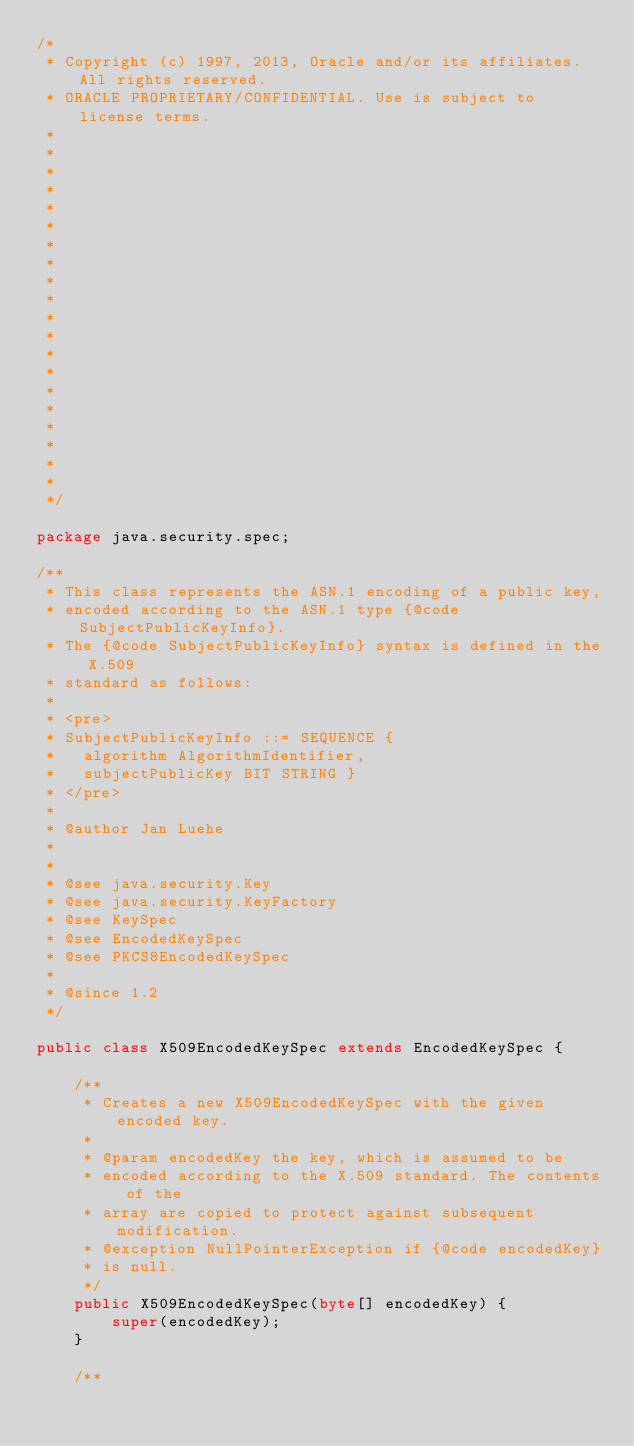Convert code to text. <code><loc_0><loc_0><loc_500><loc_500><_Java_>/*
 * Copyright (c) 1997, 2013, Oracle and/or its affiliates. All rights reserved.
 * ORACLE PROPRIETARY/CONFIDENTIAL. Use is subject to license terms.
 *
 *
 *
 *
 *
 *
 *
 *
 *
 *
 *
 *
 *
 *
 *
 *
 *
 *
 *
 *
 */

package java.security.spec;

/**
 * This class represents the ASN.1 encoding of a public key,
 * encoded according to the ASN.1 type {@code SubjectPublicKeyInfo}.
 * The {@code SubjectPublicKeyInfo} syntax is defined in the X.509
 * standard as follows:
 *
 * <pre>
 * SubjectPublicKeyInfo ::= SEQUENCE {
 *   algorithm AlgorithmIdentifier,
 *   subjectPublicKey BIT STRING }
 * </pre>
 *
 * @author Jan Luehe
 *
 *
 * @see java.security.Key
 * @see java.security.KeyFactory
 * @see KeySpec
 * @see EncodedKeySpec
 * @see PKCS8EncodedKeySpec
 *
 * @since 1.2
 */

public class X509EncodedKeySpec extends EncodedKeySpec {

    /**
     * Creates a new X509EncodedKeySpec with the given encoded key.
     *
     * @param encodedKey the key, which is assumed to be
     * encoded according to the X.509 standard. The contents of the
     * array are copied to protect against subsequent modification.
     * @exception NullPointerException if {@code encodedKey}
     * is null.
     */
    public X509EncodedKeySpec(byte[] encodedKey) {
        super(encodedKey);
    }

    /**</code> 